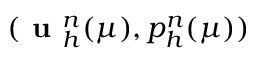Convert formula to latex. <formula><loc_0><loc_0><loc_500><loc_500>( u _ { h } ^ { n } ( \mu ) , p _ { h } ^ { n } ( \mu ) )</formula> 